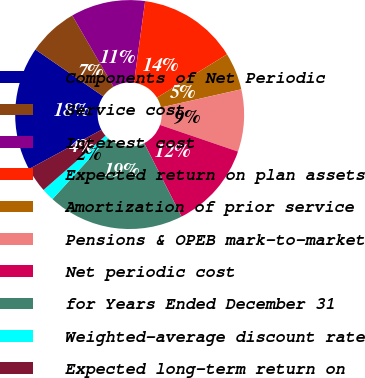Convert chart. <chart><loc_0><loc_0><loc_500><loc_500><pie_chart><fcel>Components of Net Periodic<fcel>Service cost<fcel>Interest cost<fcel>Expected return on plan assets<fcel>Amortization of prior service<fcel>Pensions & OPEB mark-to-market<fcel>Net periodic cost<fcel>for Years Ended December 31<fcel>Weighted-average discount rate<fcel>Expected long-term return on<nl><fcel>17.51%<fcel>7.03%<fcel>10.52%<fcel>14.02%<fcel>5.28%<fcel>8.78%<fcel>12.27%<fcel>19.26%<fcel>1.79%<fcel>3.54%<nl></chart> 